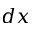Convert formula to latex. <formula><loc_0><loc_0><loc_500><loc_500>d x</formula> 